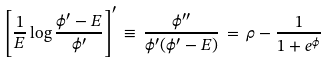<formula> <loc_0><loc_0><loc_500><loc_500>\left [ \frac { 1 } { E } \log \frac { \phi ^ { \prime } - E } { \phi ^ { \prime } } \right ] ^ { \prime } \, \equiv \, \frac { \phi ^ { \prime \prime } } { \phi ^ { \prime } ( \phi ^ { \prime } - E ) } \, = \, \rho - \frac { 1 } { 1 + e ^ { \phi } }</formula> 